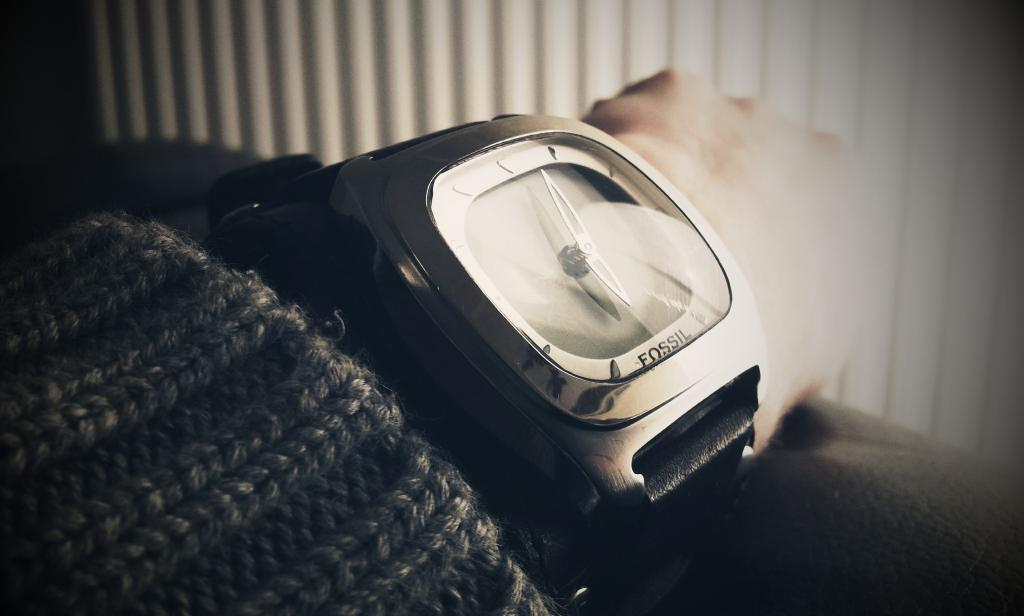<image>
Present a compact description of the photo's key features. A watch, manufactured by Fossil, is on someone's wrist. 